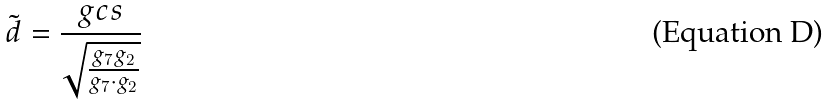<formula> <loc_0><loc_0><loc_500><loc_500>\tilde { d } = \frac { g c s } { \sqrt { \frac { g _ { 7 } g _ { 2 } } { g _ { 7 } \cdot g _ { 2 } } } }</formula> 